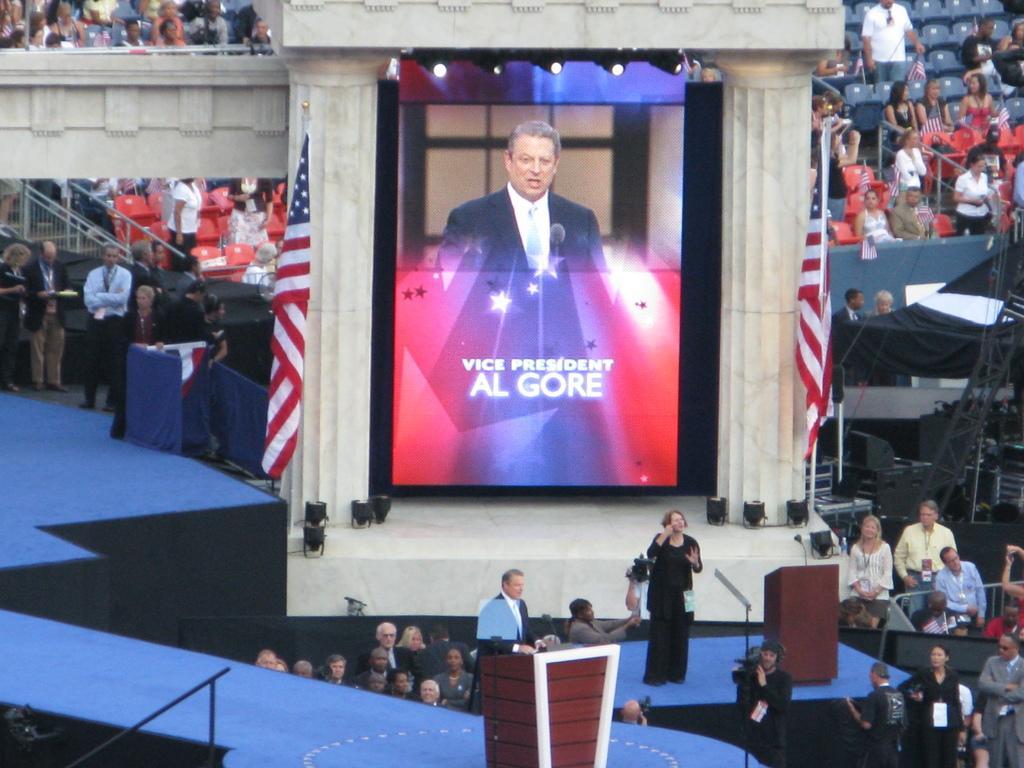How would you summarize this image in a sentence or two? There are people and this man holding a camera. We can see microphones on podiums. We can see screen,flags and lights,in this screen we can see a man and microphone. In the background we can see people,chairs and tent. 